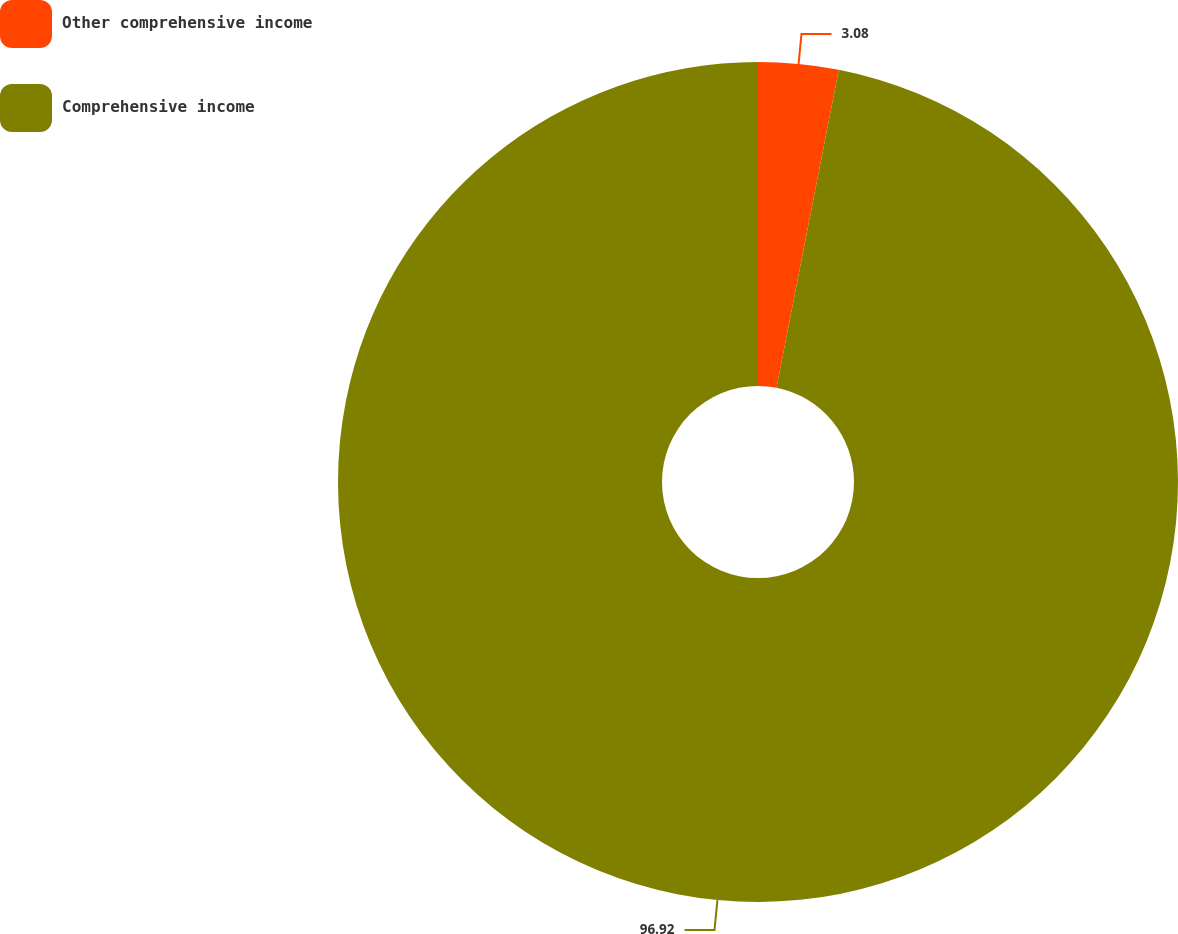Convert chart to OTSL. <chart><loc_0><loc_0><loc_500><loc_500><pie_chart><fcel>Other comprehensive income<fcel>Comprehensive income<nl><fcel>3.08%<fcel>96.92%<nl></chart> 